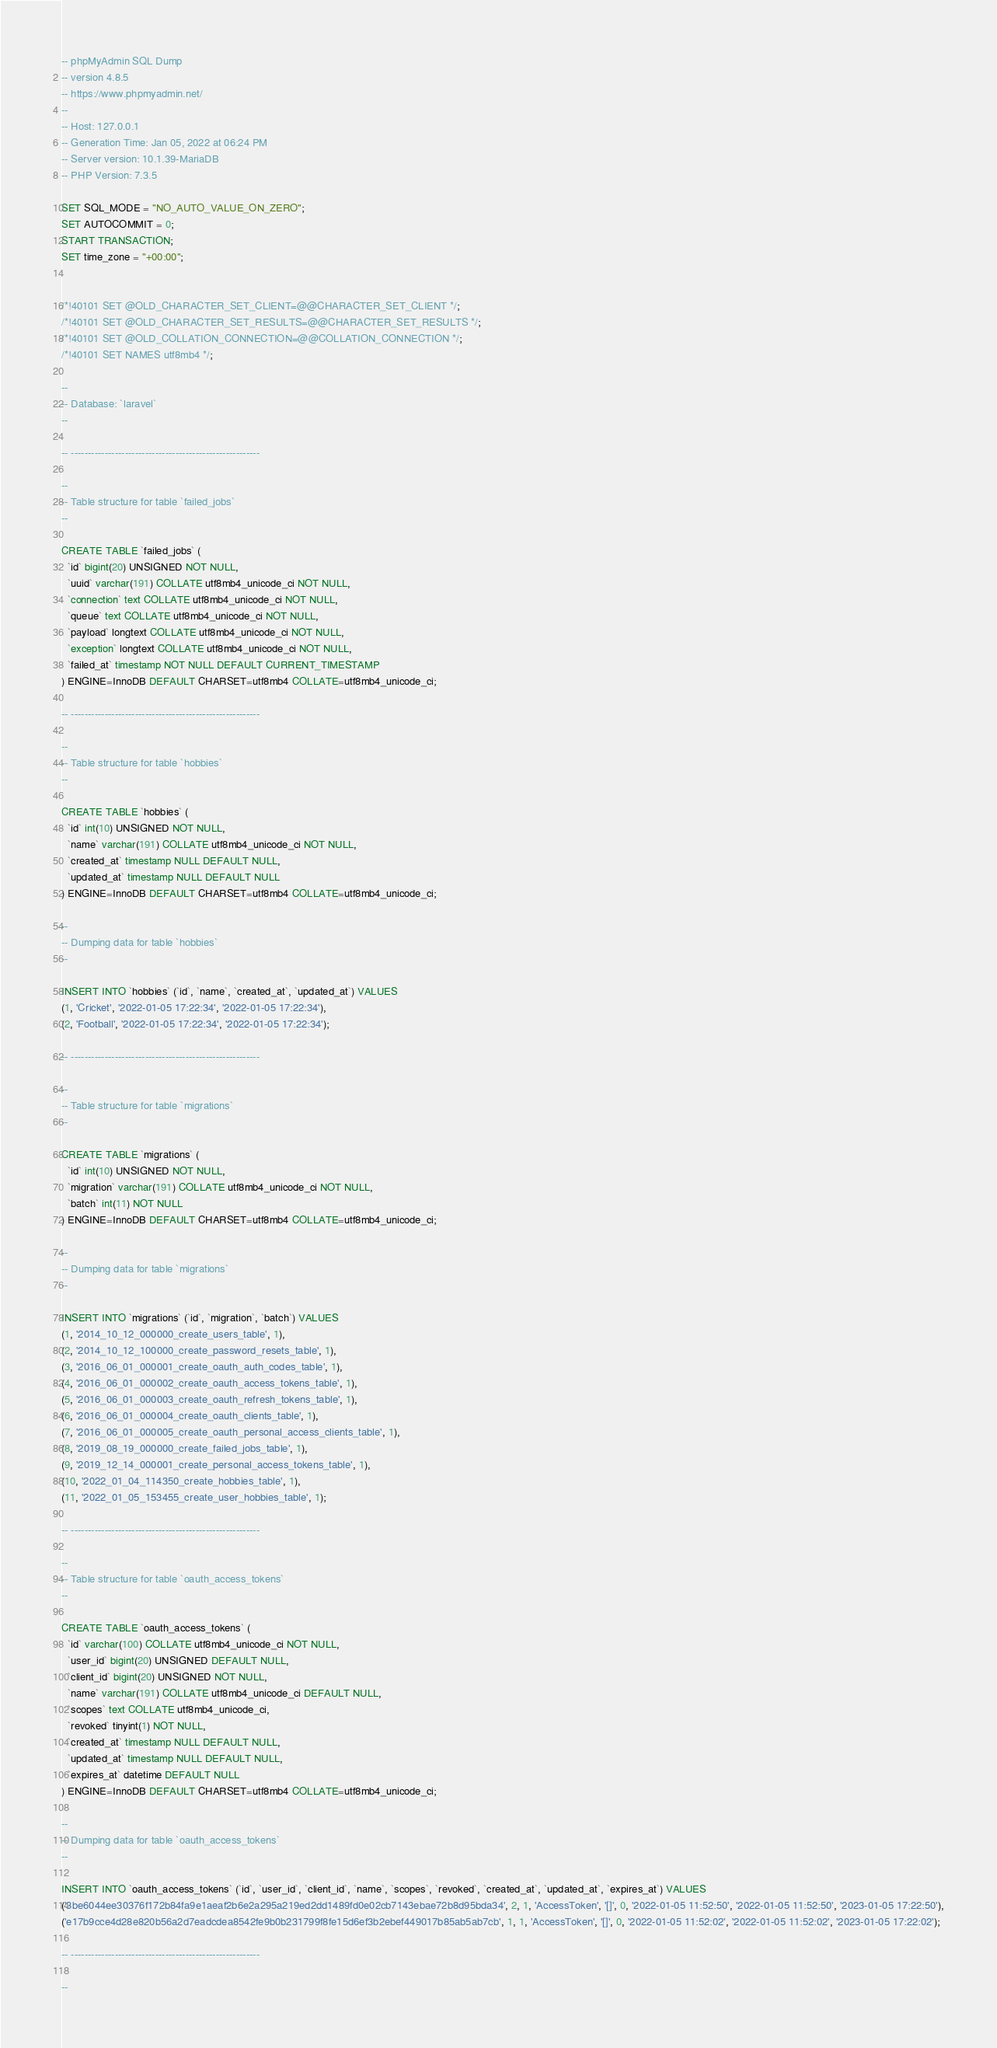<code> <loc_0><loc_0><loc_500><loc_500><_SQL_>-- phpMyAdmin SQL Dump
-- version 4.8.5
-- https://www.phpmyadmin.net/
--
-- Host: 127.0.0.1
-- Generation Time: Jan 05, 2022 at 06:24 PM
-- Server version: 10.1.39-MariaDB
-- PHP Version: 7.3.5

SET SQL_MODE = "NO_AUTO_VALUE_ON_ZERO";
SET AUTOCOMMIT = 0;
START TRANSACTION;
SET time_zone = "+00:00";


/*!40101 SET @OLD_CHARACTER_SET_CLIENT=@@CHARACTER_SET_CLIENT */;
/*!40101 SET @OLD_CHARACTER_SET_RESULTS=@@CHARACTER_SET_RESULTS */;
/*!40101 SET @OLD_COLLATION_CONNECTION=@@COLLATION_CONNECTION */;
/*!40101 SET NAMES utf8mb4 */;

--
-- Database: `laravel`
--

-- --------------------------------------------------------

--
-- Table structure for table `failed_jobs`
--

CREATE TABLE `failed_jobs` (
  `id` bigint(20) UNSIGNED NOT NULL,
  `uuid` varchar(191) COLLATE utf8mb4_unicode_ci NOT NULL,
  `connection` text COLLATE utf8mb4_unicode_ci NOT NULL,
  `queue` text COLLATE utf8mb4_unicode_ci NOT NULL,
  `payload` longtext COLLATE utf8mb4_unicode_ci NOT NULL,
  `exception` longtext COLLATE utf8mb4_unicode_ci NOT NULL,
  `failed_at` timestamp NOT NULL DEFAULT CURRENT_TIMESTAMP
) ENGINE=InnoDB DEFAULT CHARSET=utf8mb4 COLLATE=utf8mb4_unicode_ci;

-- --------------------------------------------------------

--
-- Table structure for table `hobbies`
--

CREATE TABLE `hobbies` (
  `id` int(10) UNSIGNED NOT NULL,
  `name` varchar(191) COLLATE utf8mb4_unicode_ci NOT NULL,
  `created_at` timestamp NULL DEFAULT NULL,
  `updated_at` timestamp NULL DEFAULT NULL
) ENGINE=InnoDB DEFAULT CHARSET=utf8mb4 COLLATE=utf8mb4_unicode_ci;

--
-- Dumping data for table `hobbies`
--

INSERT INTO `hobbies` (`id`, `name`, `created_at`, `updated_at`) VALUES
(1, 'Cricket', '2022-01-05 17:22:34', '2022-01-05 17:22:34'),
(2, 'Football', '2022-01-05 17:22:34', '2022-01-05 17:22:34');

-- --------------------------------------------------------

--
-- Table structure for table `migrations`
--

CREATE TABLE `migrations` (
  `id` int(10) UNSIGNED NOT NULL,
  `migration` varchar(191) COLLATE utf8mb4_unicode_ci NOT NULL,
  `batch` int(11) NOT NULL
) ENGINE=InnoDB DEFAULT CHARSET=utf8mb4 COLLATE=utf8mb4_unicode_ci;

--
-- Dumping data for table `migrations`
--

INSERT INTO `migrations` (`id`, `migration`, `batch`) VALUES
(1, '2014_10_12_000000_create_users_table', 1),
(2, '2014_10_12_100000_create_password_resets_table', 1),
(3, '2016_06_01_000001_create_oauth_auth_codes_table', 1),
(4, '2016_06_01_000002_create_oauth_access_tokens_table', 1),
(5, '2016_06_01_000003_create_oauth_refresh_tokens_table', 1),
(6, '2016_06_01_000004_create_oauth_clients_table', 1),
(7, '2016_06_01_000005_create_oauth_personal_access_clients_table', 1),
(8, '2019_08_19_000000_create_failed_jobs_table', 1),
(9, '2019_12_14_000001_create_personal_access_tokens_table', 1),
(10, '2022_01_04_114350_create_hobbies_table', 1),
(11, '2022_01_05_153455_create_user_hobbies_table', 1);

-- --------------------------------------------------------

--
-- Table structure for table `oauth_access_tokens`
--

CREATE TABLE `oauth_access_tokens` (
  `id` varchar(100) COLLATE utf8mb4_unicode_ci NOT NULL,
  `user_id` bigint(20) UNSIGNED DEFAULT NULL,
  `client_id` bigint(20) UNSIGNED NOT NULL,
  `name` varchar(191) COLLATE utf8mb4_unicode_ci DEFAULT NULL,
  `scopes` text COLLATE utf8mb4_unicode_ci,
  `revoked` tinyint(1) NOT NULL,
  `created_at` timestamp NULL DEFAULT NULL,
  `updated_at` timestamp NULL DEFAULT NULL,
  `expires_at` datetime DEFAULT NULL
) ENGINE=InnoDB DEFAULT CHARSET=utf8mb4 COLLATE=utf8mb4_unicode_ci;

--
-- Dumping data for table `oauth_access_tokens`
--

INSERT INTO `oauth_access_tokens` (`id`, `user_id`, `client_id`, `name`, `scopes`, `revoked`, `created_at`, `updated_at`, `expires_at`) VALUES
('3be6044ee30376f172b84fa9e1aeaf2b6e2a295a219ed2dd1489fd0e02cb7143ebae72b8d95bda34', 2, 1, 'AccessToken', '[]', 0, '2022-01-05 11:52:50', '2022-01-05 11:52:50', '2023-01-05 17:22:50'),
('e17b9cce4d28e820b56a2d7eadcdea8542fe9b0b231799f8fe15d6ef3b2ebef449017b85ab5ab7cb', 1, 1, 'AccessToken', '[]', 0, '2022-01-05 11:52:02', '2022-01-05 11:52:02', '2023-01-05 17:22:02');

-- --------------------------------------------------------

--</code> 